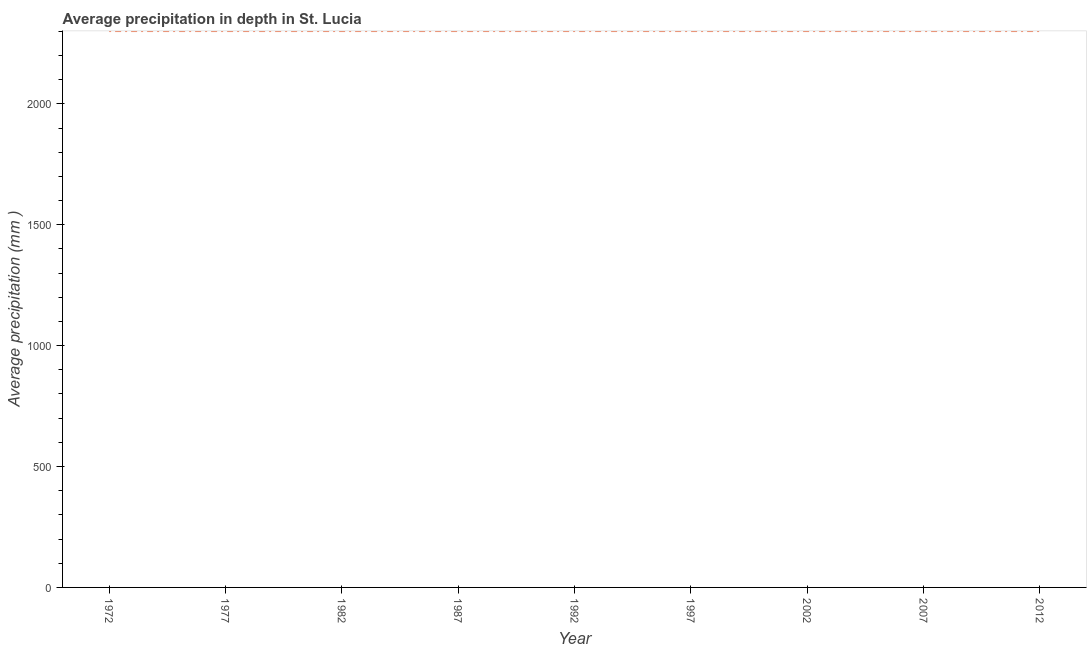What is the average precipitation in depth in 1977?
Keep it short and to the point. 2301. Across all years, what is the maximum average precipitation in depth?
Your answer should be very brief. 2301. Across all years, what is the minimum average precipitation in depth?
Your answer should be very brief. 2301. In which year was the average precipitation in depth minimum?
Give a very brief answer. 1972. What is the sum of the average precipitation in depth?
Give a very brief answer. 2.07e+04. What is the difference between the average precipitation in depth in 1982 and 2002?
Provide a short and direct response. 0. What is the average average precipitation in depth per year?
Offer a terse response. 2301. What is the median average precipitation in depth?
Give a very brief answer. 2301. In how many years, is the average precipitation in depth greater than 900 mm?
Provide a succinct answer. 9. What is the ratio of the average precipitation in depth in 1972 to that in 2012?
Your answer should be compact. 1. Is the average precipitation in depth in 2007 less than that in 2012?
Your answer should be very brief. No. What is the difference between the highest and the second highest average precipitation in depth?
Offer a terse response. 0. Is the sum of the average precipitation in depth in 1997 and 2002 greater than the maximum average precipitation in depth across all years?
Offer a very short reply. Yes. In how many years, is the average precipitation in depth greater than the average average precipitation in depth taken over all years?
Your response must be concise. 0. Does the average precipitation in depth monotonically increase over the years?
Offer a very short reply. No. How many lines are there?
Make the answer very short. 1. How many years are there in the graph?
Offer a terse response. 9. What is the difference between two consecutive major ticks on the Y-axis?
Keep it short and to the point. 500. Does the graph contain any zero values?
Your answer should be compact. No. What is the title of the graph?
Provide a succinct answer. Average precipitation in depth in St. Lucia. What is the label or title of the Y-axis?
Offer a terse response. Average precipitation (mm ). What is the Average precipitation (mm ) in 1972?
Keep it short and to the point. 2301. What is the Average precipitation (mm ) of 1977?
Your answer should be very brief. 2301. What is the Average precipitation (mm ) of 1982?
Your answer should be compact. 2301. What is the Average precipitation (mm ) of 1987?
Give a very brief answer. 2301. What is the Average precipitation (mm ) in 1992?
Your answer should be compact. 2301. What is the Average precipitation (mm ) of 1997?
Your answer should be very brief. 2301. What is the Average precipitation (mm ) in 2002?
Ensure brevity in your answer.  2301. What is the Average precipitation (mm ) of 2007?
Your answer should be very brief. 2301. What is the Average precipitation (mm ) in 2012?
Ensure brevity in your answer.  2301. What is the difference between the Average precipitation (mm ) in 1977 and 1982?
Your answer should be very brief. 0. What is the difference between the Average precipitation (mm ) in 1977 and 2002?
Provide a succinct answer. 0. What is the difference between the Average precipitation (mm ) in 1982 and 1992?
Keep it short and to the point. 0. What is the difference between the Average precipitation (mm ) in 1982 and 1997?
Make the answer very short. 0. What is the difference between the Average precipitation (mm ) in 1982 and 2012?
Keep it short and to the point. 0. What is the difference between the Average precipitation (mm ) in 1987 and 1992?
Offer a terse response. 0. What is the difference between the Average precipitation (mm ) in 1987 and 1997?
Keep it short and to the point. 0. What is the difference between the Average precipitation (mm ) in 1987 and 2002?
Your answer should be very brief. 0. What is the difference between the Average precipitation (mm ) in 1987 and 2007?
Your answer should be very brief. 0. What is the difference between the Average precipitation (mm ) in 1992 and 1997?
Your response must be concise. 0. What is the difference between the Average precipitation (mm ) in 1992 and 2002?
Provide a succinct answer. 0. What is the difference between the Average precipitation (mm ) in 1992 and 2012?
Your answer should be very brief. 0. What is the difference between the Average precipitation (mm ) in 1997 and 2002?
Provide a succinct answer. 0. What is the difference between the Average precipitation (mm ) in 2002 and 2007?
Your answer should be very brief. 0. What is the difference between the Average precipitation (mm ) in 2002 and 2012?
Give a very brief answer. 0. What is the difference between the Average precipitation (mm ) in 2007 and 2012?
Give a very brief answer. 0. What is the ratio of the Average precipitation (mm ) in 1972 to that in 1977?
Ensure brevity in your answer.  1. What is the ratio of the Average precipitation (mm ) in 1972 to that in 1982?
Offer a terse response. 1. What is the ratio of the Average precipitation (mm ) in 1972 to that in 1987?
Offer a terse response. 1. What is the ratio of the Average precipitation (mm ) in 1972 to that in 1997?
Ensure brevity in your answer.  1. What is the ratio of the Average precipitation (mm ) in 1972 to that in 2007?
Provide a short and direct response. 1. What is the ratio of the Average precipitation (mm ) in 1977 to that in 1982?
Provide a short and direct response. 1. What is the ratio of the Average precipitation (mm ) in 1977 to that in 1987?
Your response must be concise. 1. What is the ratio of the Average precipitation (mm ) in 1977 to that in 2007?
Your response must be concise. 1. What is the ratio of the Average precipitation (mm ) in 1977 to that in 2012?
Keep it short and to the point. 1. What is the ratio of the Average precipitation (mm ) in 1982 to that in 1987?
Offer a terse response. 1. What is the ratio of the Average precipitation (mm ) in 1982 to that in 1997?
Give a very brief answer. 1. What is the ratio of the Average precipitation (mm ) in 1982 to that in 2007?
Offer a very short reply. 1. What is the ratio of the Average precipitation (mm ) in 1987 to that in 1992?
Your answer should be very brief. 1. What is the ratio of the Average precipitation (mm ) in 1987 to that in 1997?
Provide a short and direct response. 1. What is the ratio of the Average precipitation (mm ) in 1987 to that in 2002?
Offer a very short reply. 1. What is the ratio of the Average precipitation (mm ) in 1987 to that in 2012?
Ensure brevity in your answer.  1. What is the ratio of the Average precipitation (mm ) in 1992 to that in 2002?
Give a very brief answer. 1. What is the ratio of the Average precipitation (mm ) in 1992 to that in 2007?
Provide a succinct answer. 1. What is the ratio of the Average precipitation (mm ) in 1997 to that in 2002?
Provide a succinct answer. 1. What is the ratio of the Average precipitation (mm ) in 1997 to that in 2007?
Your answer should be compact. 1. What is the ratio of the Average precipitation (mm ) in 2002 to that in 2007?
Provide a succinct answer. 1. What is the ratio of the Average precipitation (mm ) in 2007 to that in 2012?
Make the answer very short. 1. 